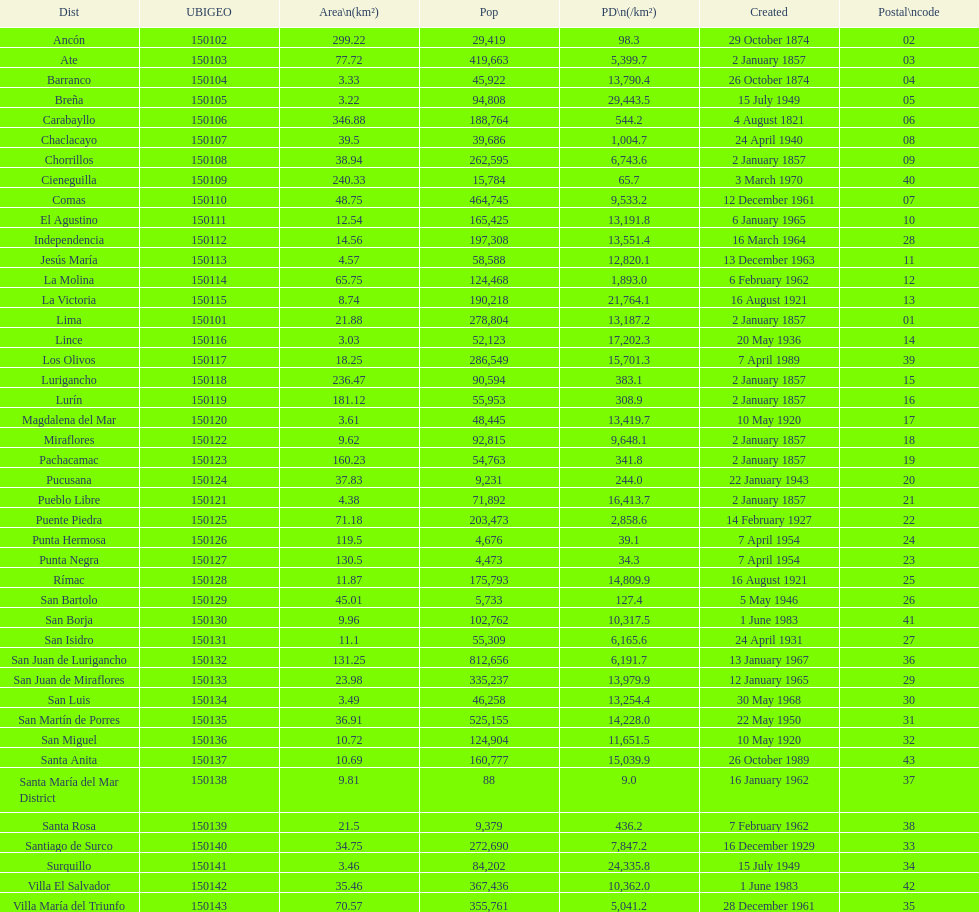0? 31. 